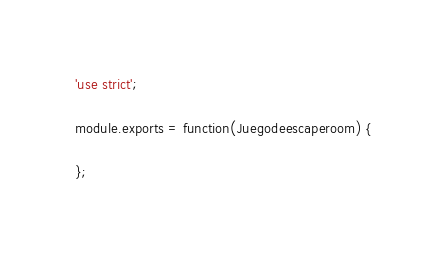<code> <loc_0><loc_0><loc_500><loc_500><_JavaScript_>'use strict';

module.exports = function(Juegodeescaperoom) {

};
</code> 